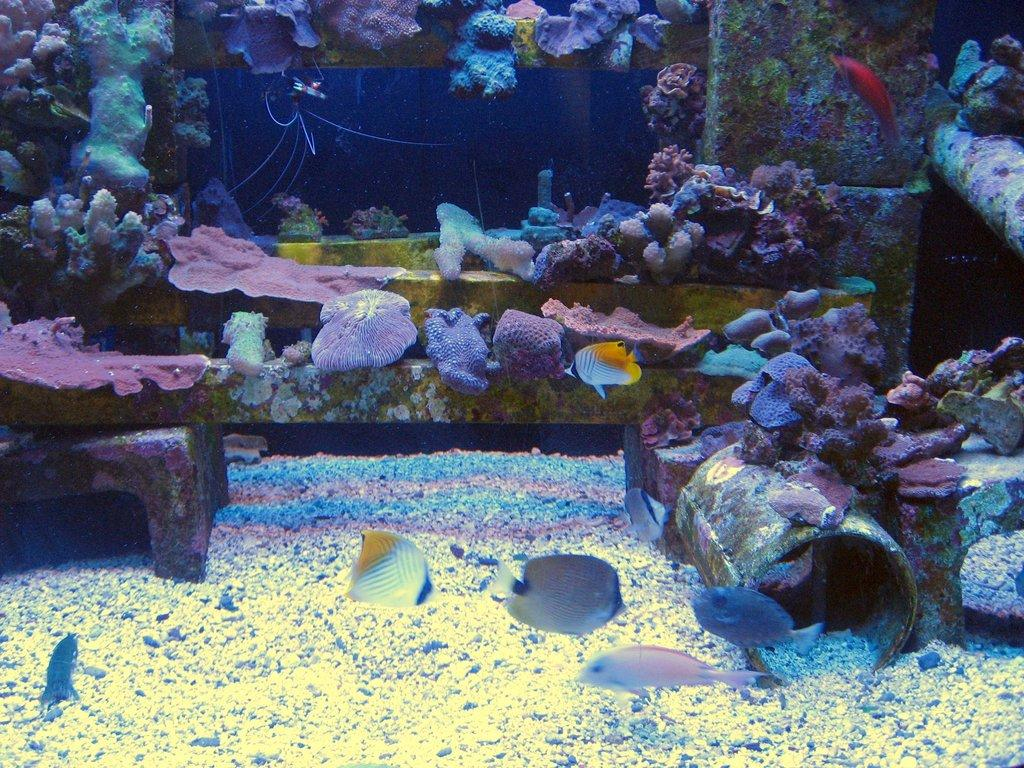What type of animals can be seen in the image? There are many aquatic animals in the image. Can you describe the appearance of the aquatic animals? The aquatic animals are colorful. What else is present in the water with the aquatic animals? There are rocks in the image. How do the rocks contribute to the visual appeal of the image? The rocks are in different colors, adding variety to the scene. What type of steel structure can be seen in the image? There is no steel structure present in the image; it features aquatic animals and rocks in the water. How does the popcorn contribute to the image? There is no popcorn present in the image; it focuses on aquatic animals and rocks in the water. 